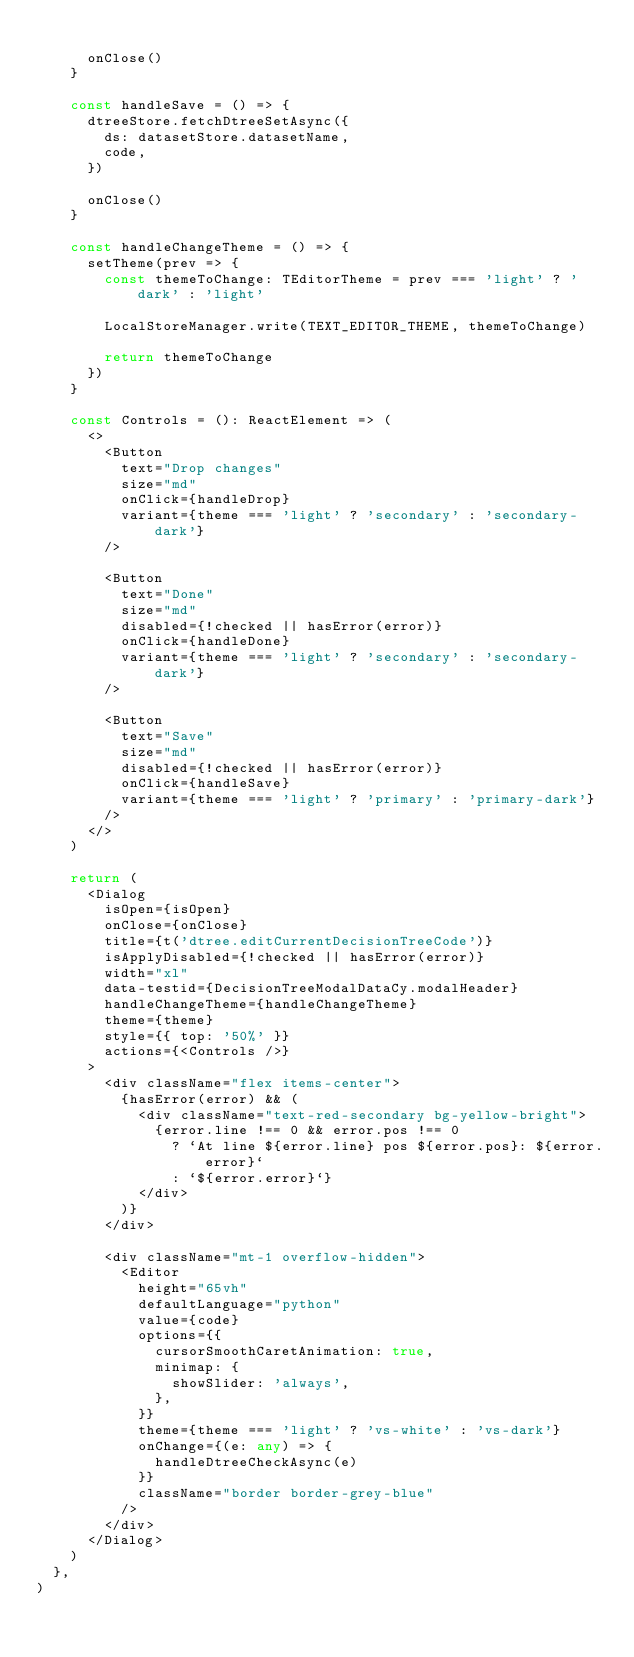Convert code to text. <code><loc_0><loc_0><loc_500><loc_500><_TypeScript_>
      onClose()
    }

    const handleSave = () => {
      dtreeStore.fetchDtreeSetAsync({
        ds: datasetStore.datasetName,
        code,
      })

      onClose()
    }

    const handleChangeTheme = () => {
      setTheme(prev => {
        const themeToChange: TEditorTheme = prev === 'light' ? 'dark' : 'light'

        LocalStoreManager.write(TEXT_EDITOR_THEME, themeToChange)

        return themeToChange
      })
    }

    const Controls = (): ReactElement => (
      <>
        <Button
          text="Drop changes"
          size="md"
          onClick={handleDrop}
          variant={theme === 'light' ? 'secondary' : 'secondary-dark'}
        />

        <Button
          text="Done"
          size="md"
          disabled={!checked || hasError(error)}
          onClick={handleDone}
          variant={theme === 'light' ? 'secondary' : 'secondary-dark'}
        />

        <Button
          text="Save"
          size="md"
          disabled={!checked || hasError(error)}
          onClick={handleSave}
          variant={theme === 'light' ? 'primary' : 'primary-dark'}
        />
      </>
    )

    return (
      <Dialog
        isOpen={isOpen}
        onClose={onClose}
        title={t('dtree.editCurrentDecisionTreeCode')}
        isApplyDisabled={!checked || hasError(error)}
        width="xl"
        data-testid={DecisionTreeModalDataCy.modalHeader}
        handleChangeTheme={handleChangeTheme}
        theme={theme}
        style={{ top: '50%' }}
        actions={<Controls />}
      >
        <div className="flex items-center">
          {hasError(error) && (
            <div className="text-red-secondary bg-yellow-bright">
              {error.line !== 0 && error.pos !== 0
                ? `At line ${error.line} pos ${error.pos}: ${error.error}`
                : `${error.error}`}
            </div>
          )}
        </div>

        <div className="mt-1 overflow-hidden">
          <Editor
            height="65vh"
            defaultLanguage="python"
            value={code}
            options={{
              cursorSmoothCaretAnimation: true,
              minimap: {
                showSlider: 'always',
              },
            }}
            theme={theme === 'light' ? 'vs-white' : 'vs-dark'}
            onChange={(e: any) => {
              handleDtreeCheckAsync(e)
            }}
            className="border border-grey-blue"
          />
        </div>
      </Dialog>
    )
  },
)
</code> 